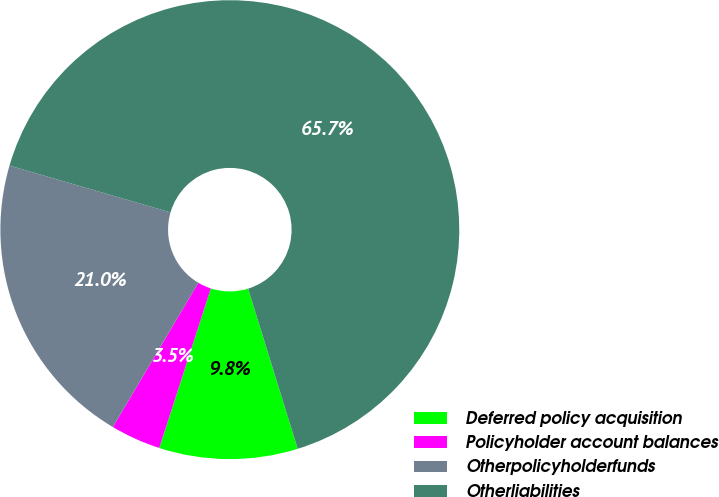Convert chart to OTSL. <chart><loc_0><loc_0><loc_500><loc_500><pie_chart><fcel>Deferred policy acquisition<fcel>Policyholder account balances<fcel>Otherpolicyholderfunds<fcel>Otherliabilities<nl><fcel>9.76%<fcel>3.54%<fcel>20.99%<fcel>65.72%<nl></chart> 